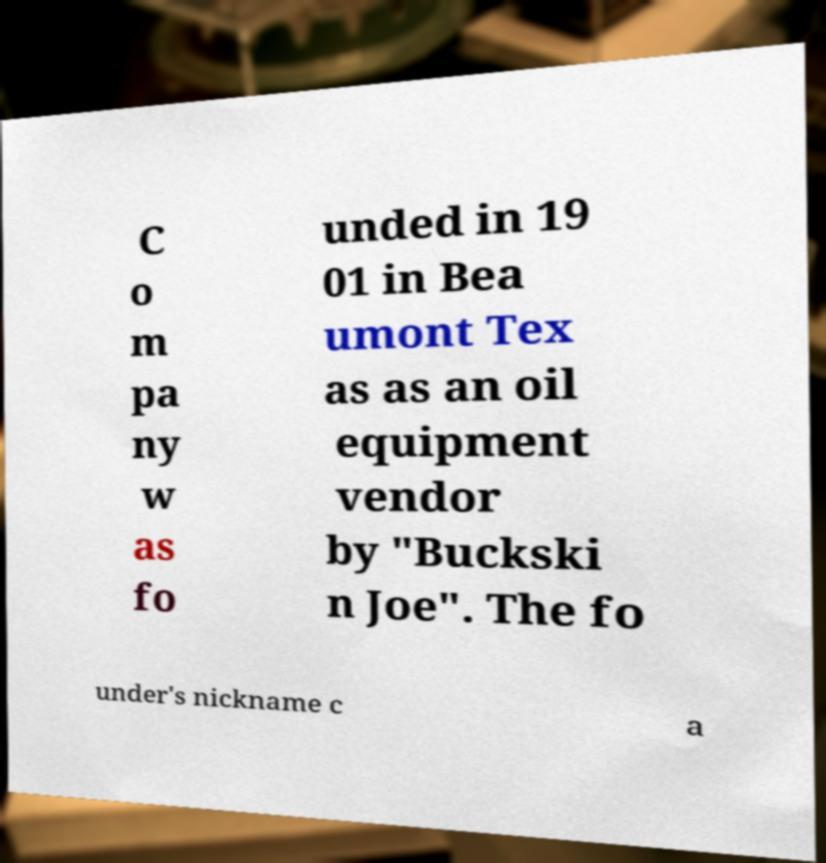Can you accurately transcribe the text from the provided image for me? C o m pa ny w as fo unded in 19 01 in Bea umont Tex as as an oil equipment vendor by "Buckski n Joe". The fo under's nickname c a 